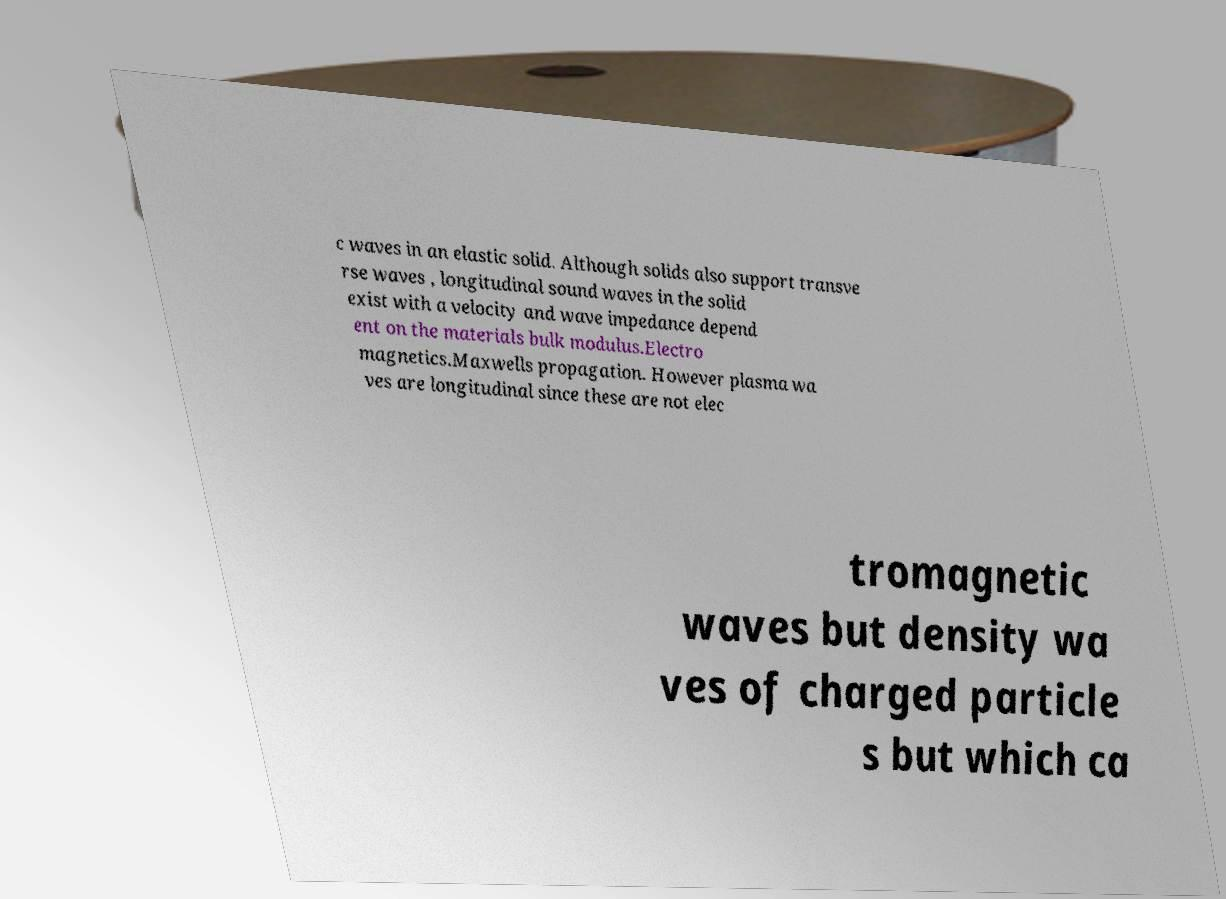Please read and relay the text visible in this image. What does it say? c waves in an elastic solid. Although solids also support transve rse waves , longitudinal sound waves in the solid exist with a velocity and wave impedance depend ent on the materials bulk modulus.Electro magnetics.Maxwells propagation. However plasma wa ves are longitudinal since these are not elec tromagnetic waves but density wa ves of charged particle s but which ca 